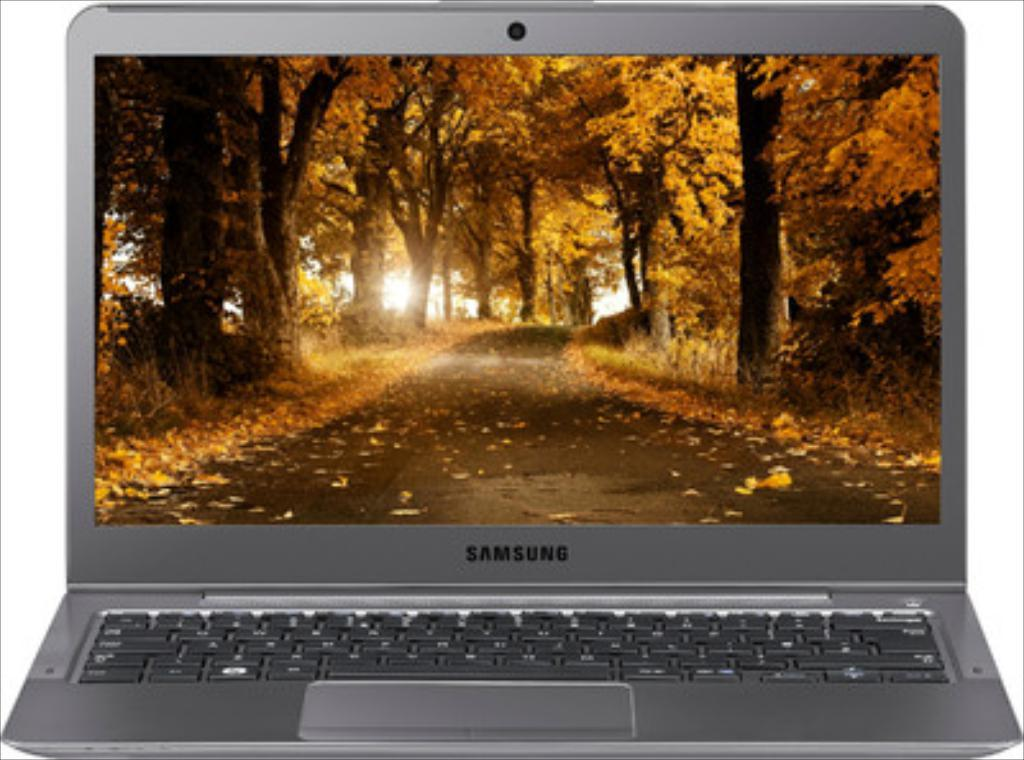Provide a one-sentence caption for the provided image. A grey Samsung laptop with a screen showing orange Fall leaves. 